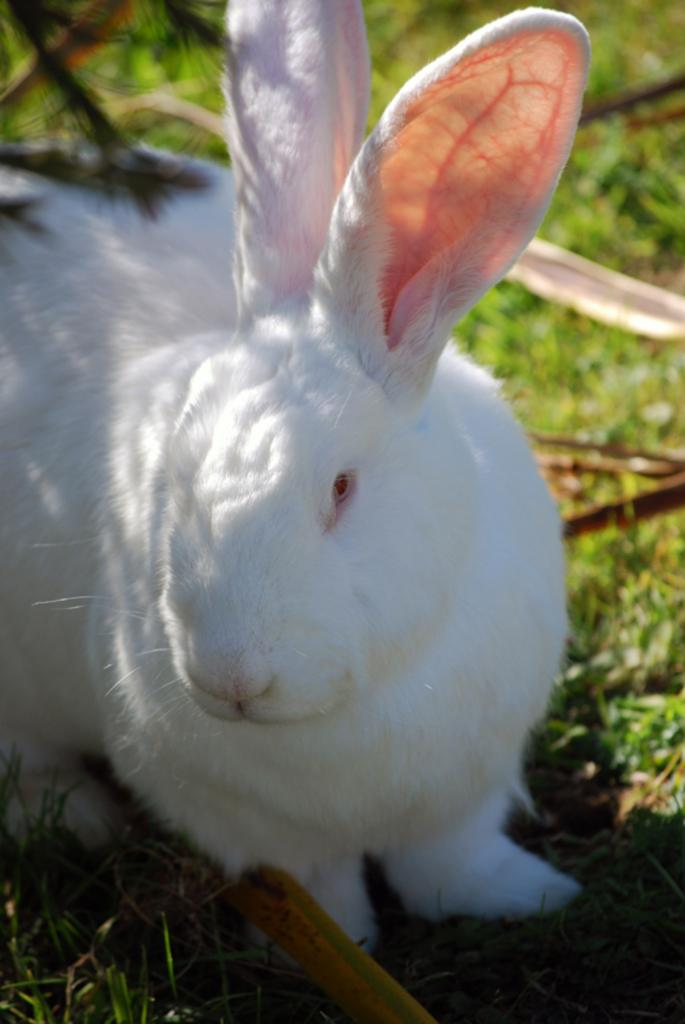What animal is present in the image? There is a rabbit in the picture. What type of surface is the rabbit on? The rabbit is on a grass surface. What type of popcorn is the rabbit eating in the image? There is no popcorn present in the image; the rabbit is on a grass surface. Can you read the note that the rabbit is holding in the image? There is no note present in the image; the rabbit is simply on a grass surface. 